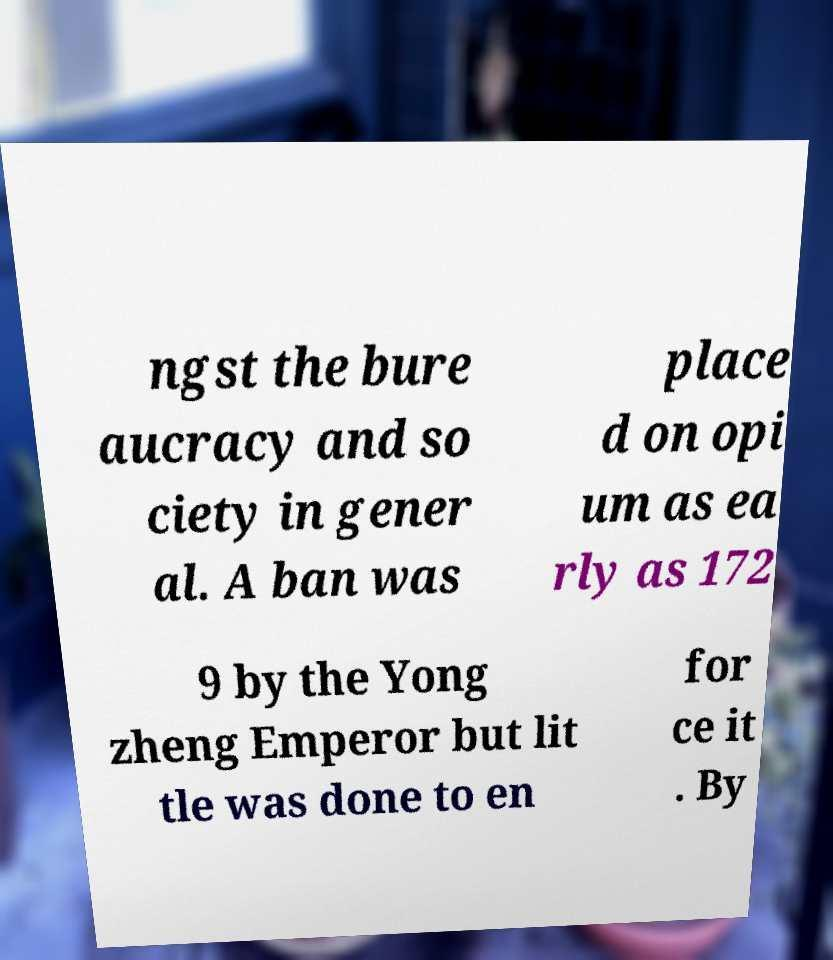I need the written content from this picture converted into text. Can you do that? ngst the bure aucracy and so ciety in gener al. A ban was place d on opi um as ea rly as 172 9 by the Yong zheng Emperor but lit tle was done to en for ce it . By 